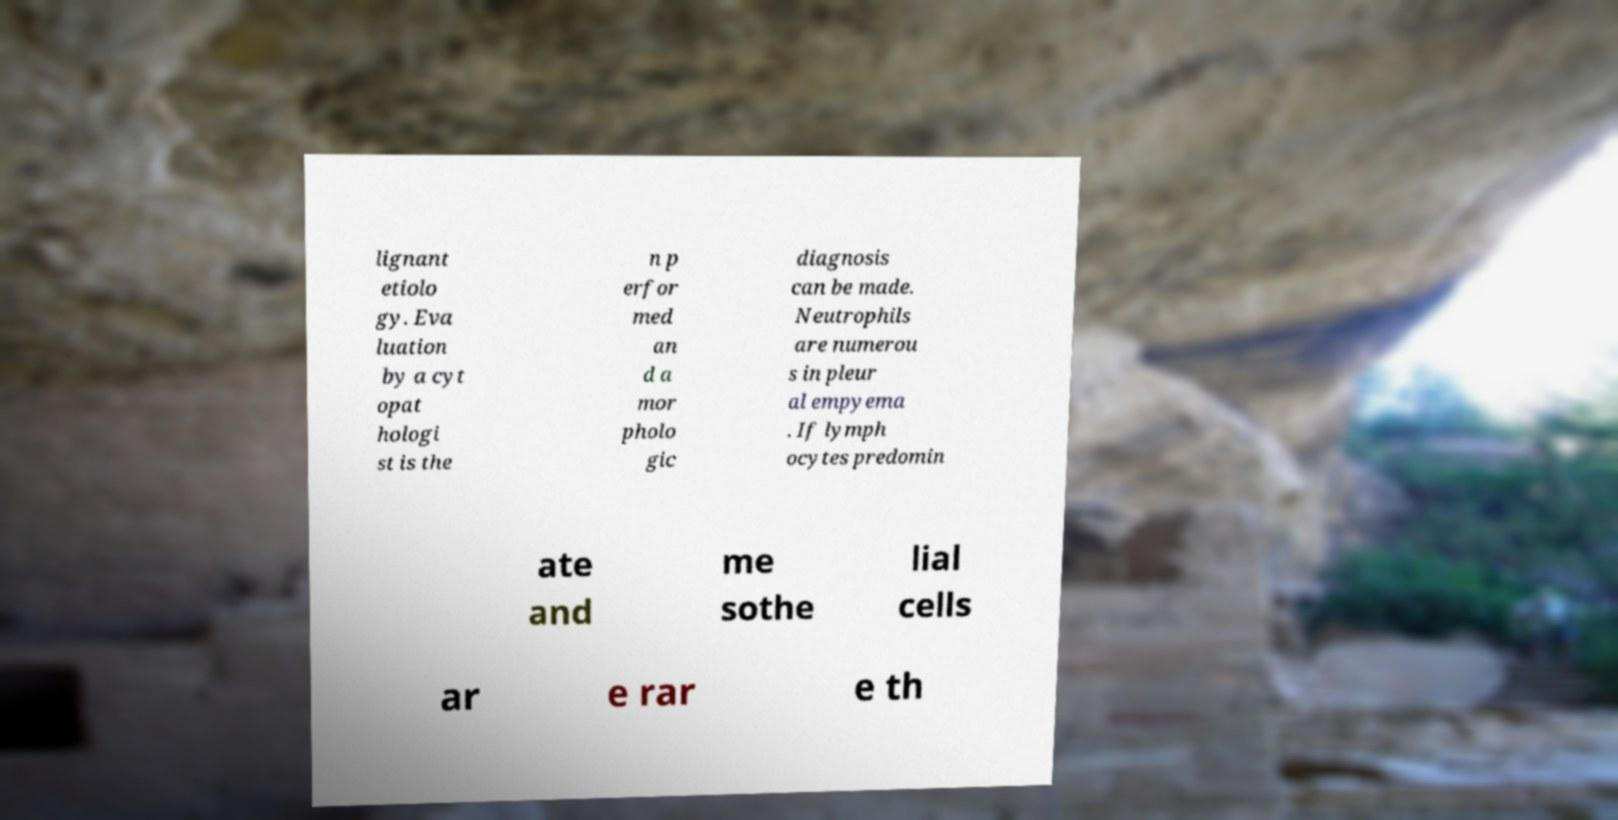Could you extract and type out the text from this image? lignant etiolo gy. Eva luation by a cyt opat hologi st is the n p erfor med an d a mor pholo gic diagnosis can be made. Neutrophils are numerou s in pleur al empyema . If lymph ocytes predomin ate and me sothe lial cells ar e rar e th 